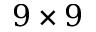<formula> <loc_0><loc_0><loc_500><loc_500>9 \times 9</formula> 